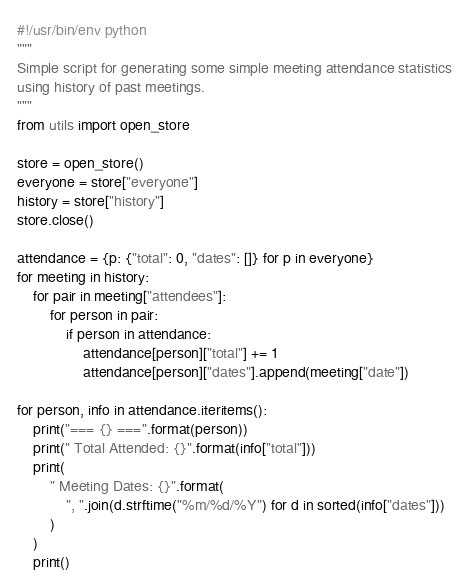<code> <loc_0><loc_0><loc_500><loc_500><_Python_>#!/usr/bin/env python
"""
Simple script for generating some simple meeting attendance statistics
using history of past meetings.
"""
from utils import open_store

store = open_store()
everyone = store["everyone"]
history = store["history"]
store.close()

attendance = {p: {"total": 0, "dates": []} for p in everyone}
for meeting in history:
    for pair in meeting["attendees"]:
        for person in pair:
            if person in attendance:
                attendance[person]["total"] += 1
                attendance[person]["dates"].append(meeting["date"])

for person, info in attendance.iteritems():
    print("=== {} ===".format(person))
    print(" Total Attended: {}".format(info["total"]))
    print(
        " Meeting Dates: {}".format(
            ", ".join(d.strftime("%m/%d/%Y") for d in sorted(info["dates"]))
        )
    )
    print()
</code> 